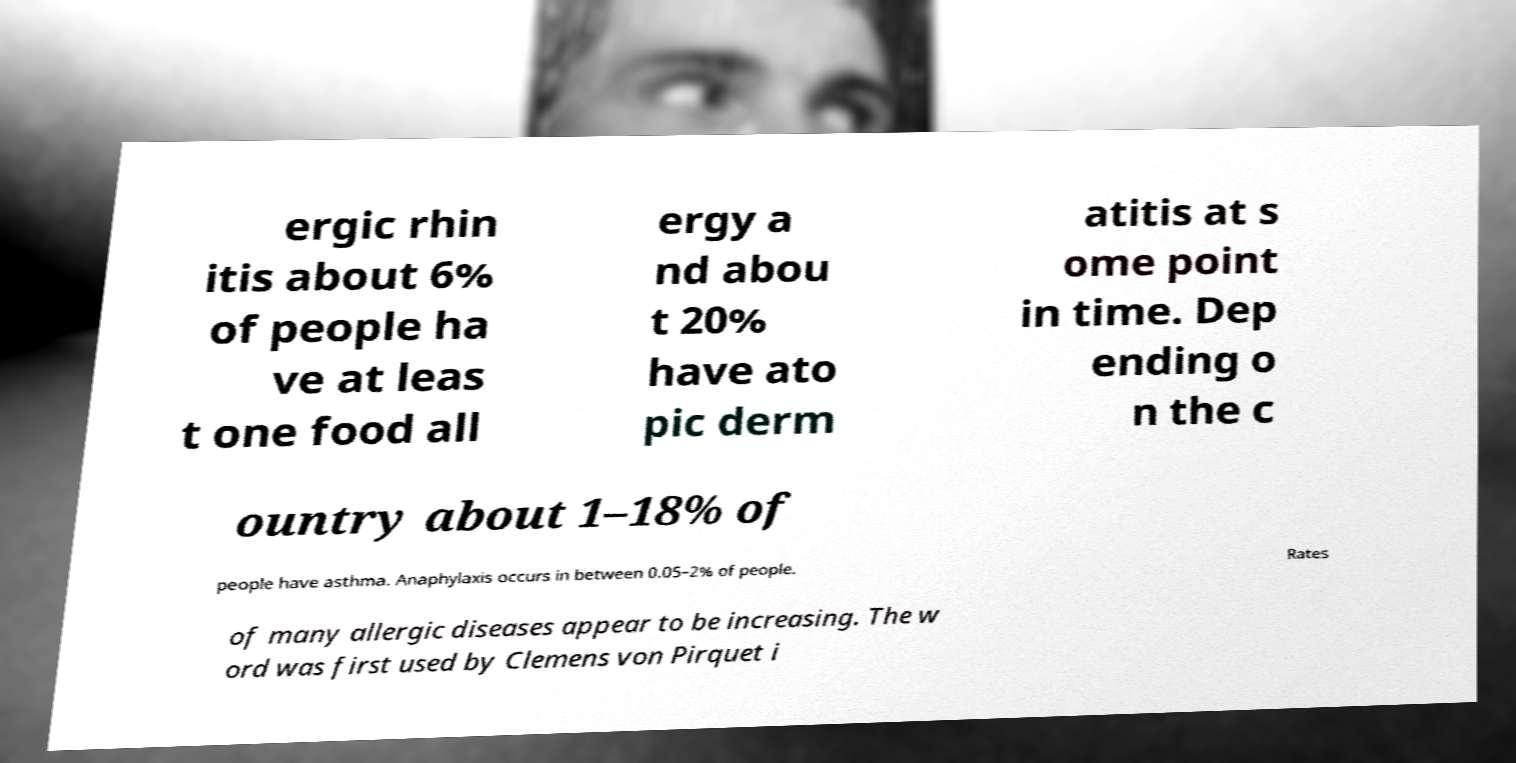Could you extract and type out the text from this image? ergic rhin itis about 6% of people ha ve at leas t one food all ergy a nd abou t 20% have ato pic derm atitis at s ome point in time. Dep ending o n the c ountry about 1–18% of people have asthma. Anaphylaxis occurs in between 0.05–2% of people. Rates of many allergic diseases appear to be increasing. The w ord was first used by Clemens von Pirquet i 